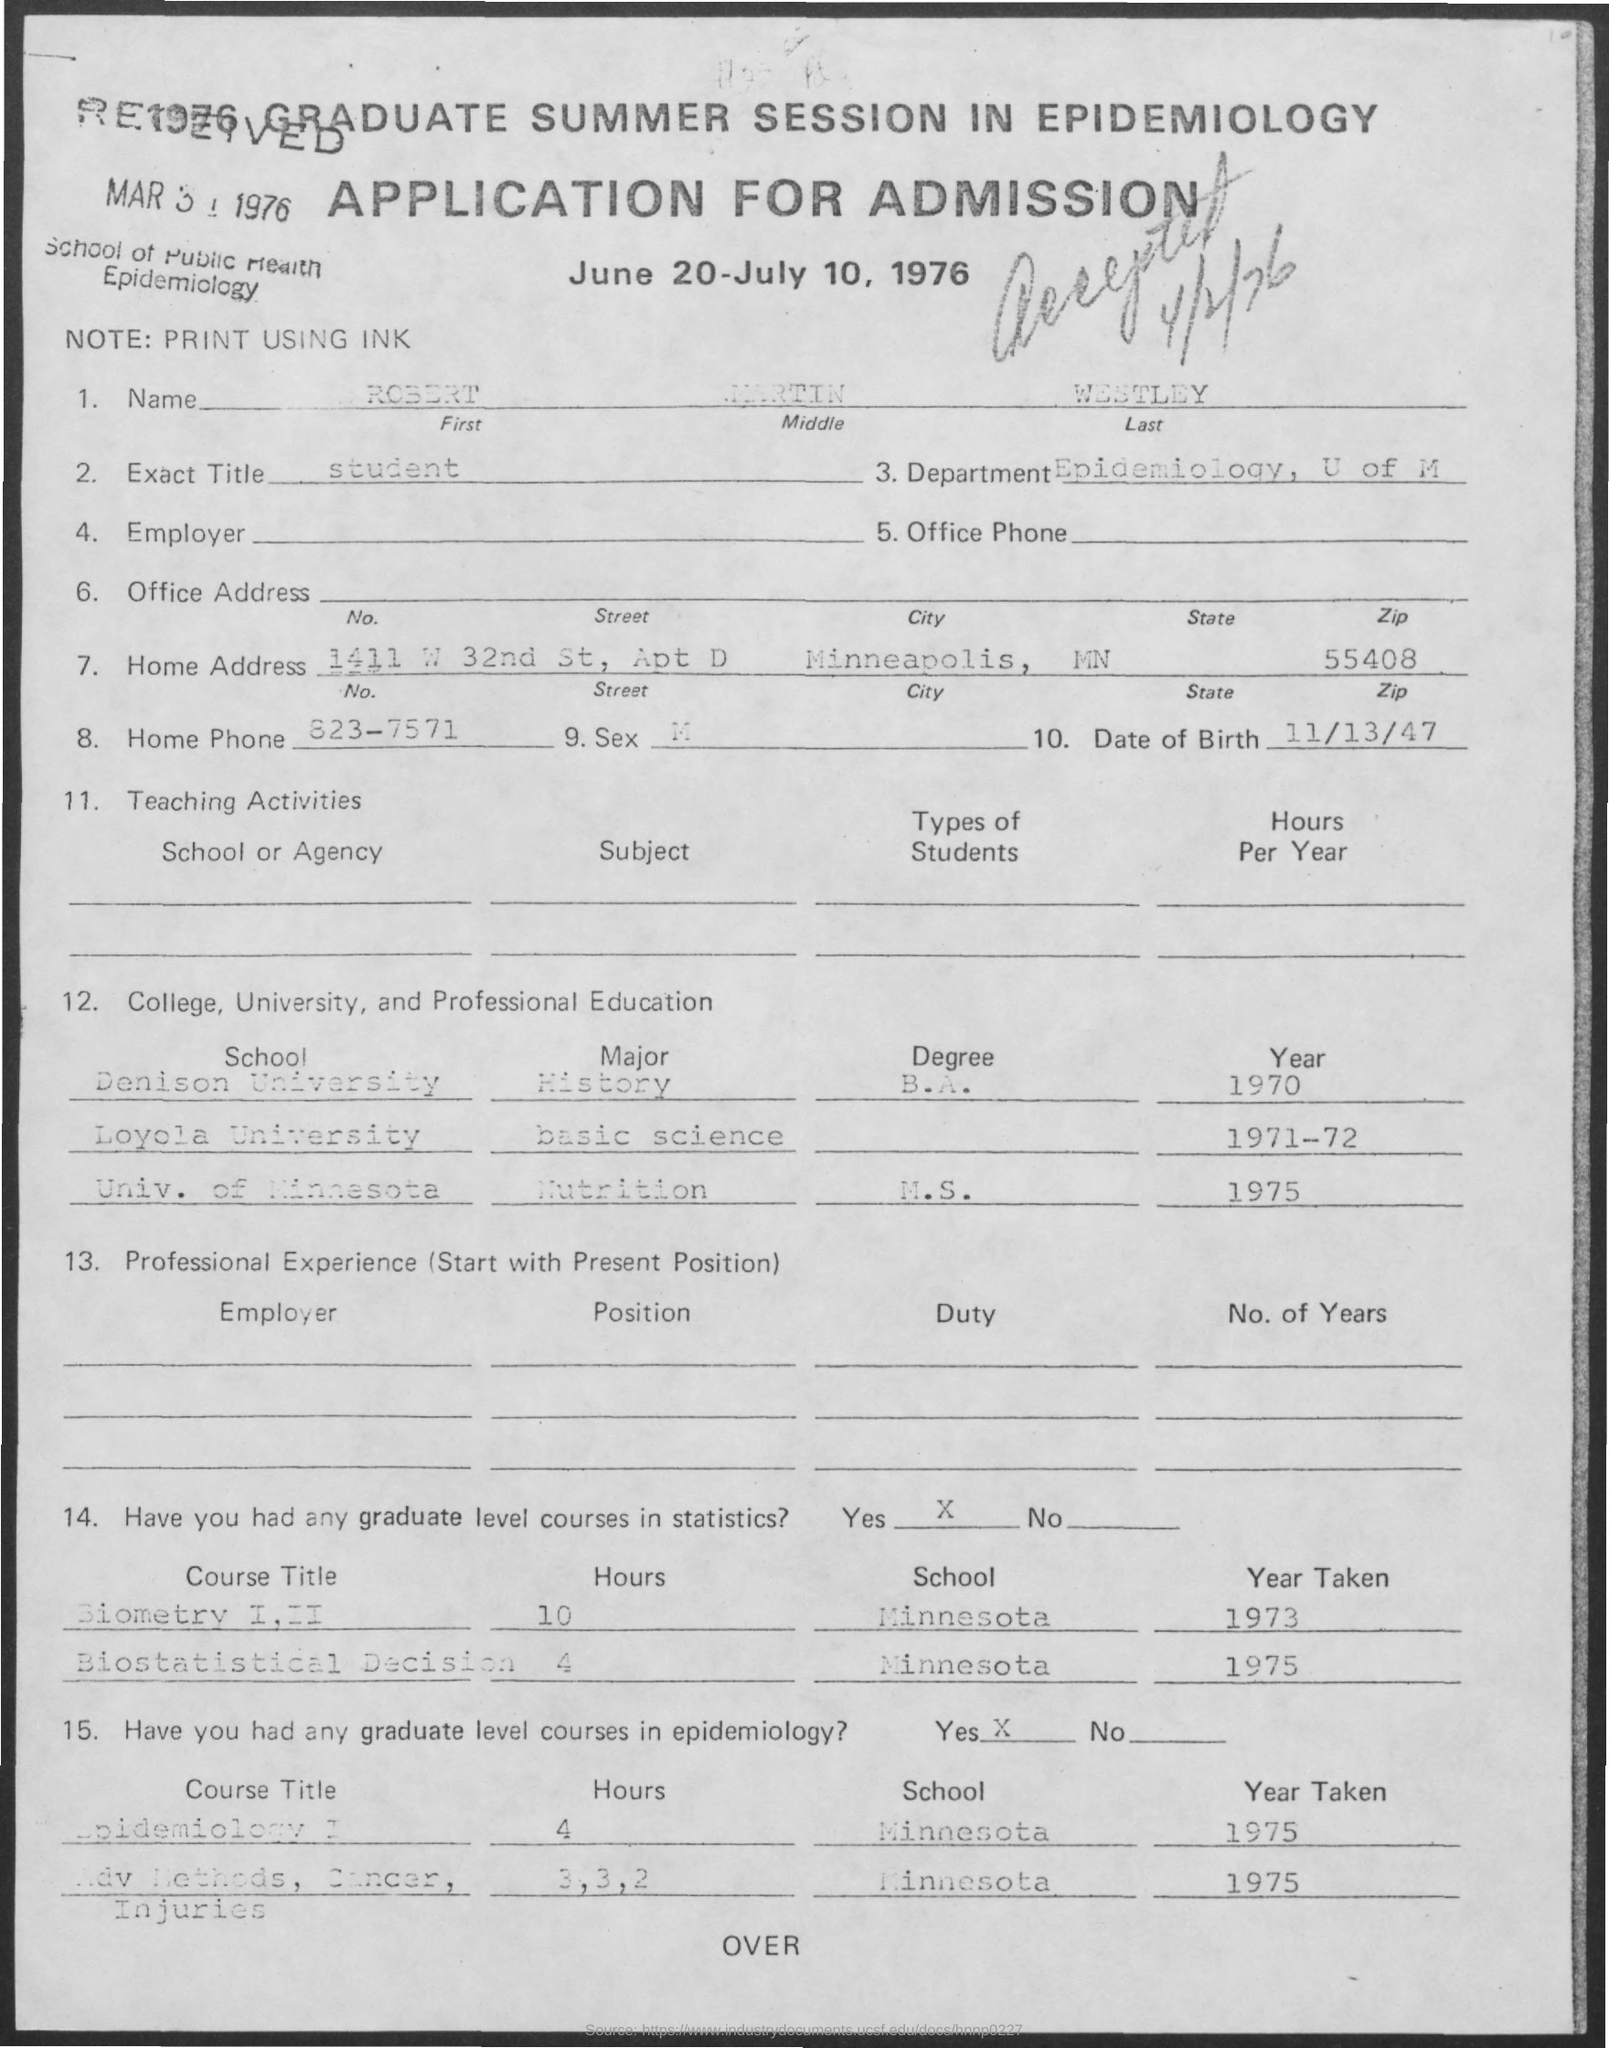Highlight a few significant elements in this photo. The exact title of the student is unknown. The person is a member of the Epidemiology department at the University of Michigan. On November 13, 1947, a person was born. The name mentioned is Robert Martin Westley. 